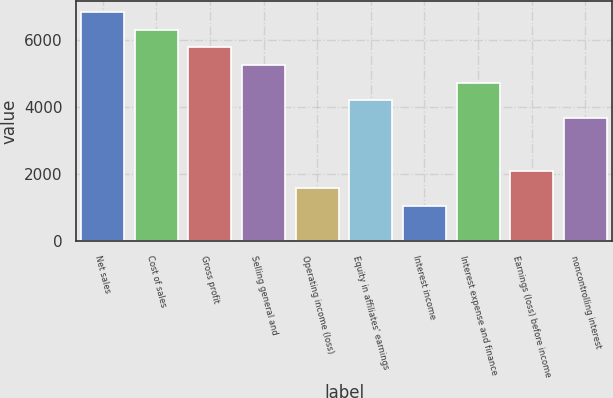Convert chart to OTSL. <chart><loc_0><loc_0><loc_500><loc_500><bar_chart><fcel>Net sales<fcel>Cost of sales<fcel>Gross profit<fcel>Selling general and<fcel>Operating income (loss)<fcel>Equity in affiliates' earnings<fcel>Interest income<fcel>Interest expense and finance<fcel>Earnings (loss) before income<fcel>noncontrolling interest<nl><fcel>6842.99<fcel>6316.63<fcel>5790.27<fcel>5263.91<fcel>1579.39<fcel>4211.19<fcel>1053.03<fcel>4737.55<fcel>2105.75<fcel>3684.83<nl></chart> 